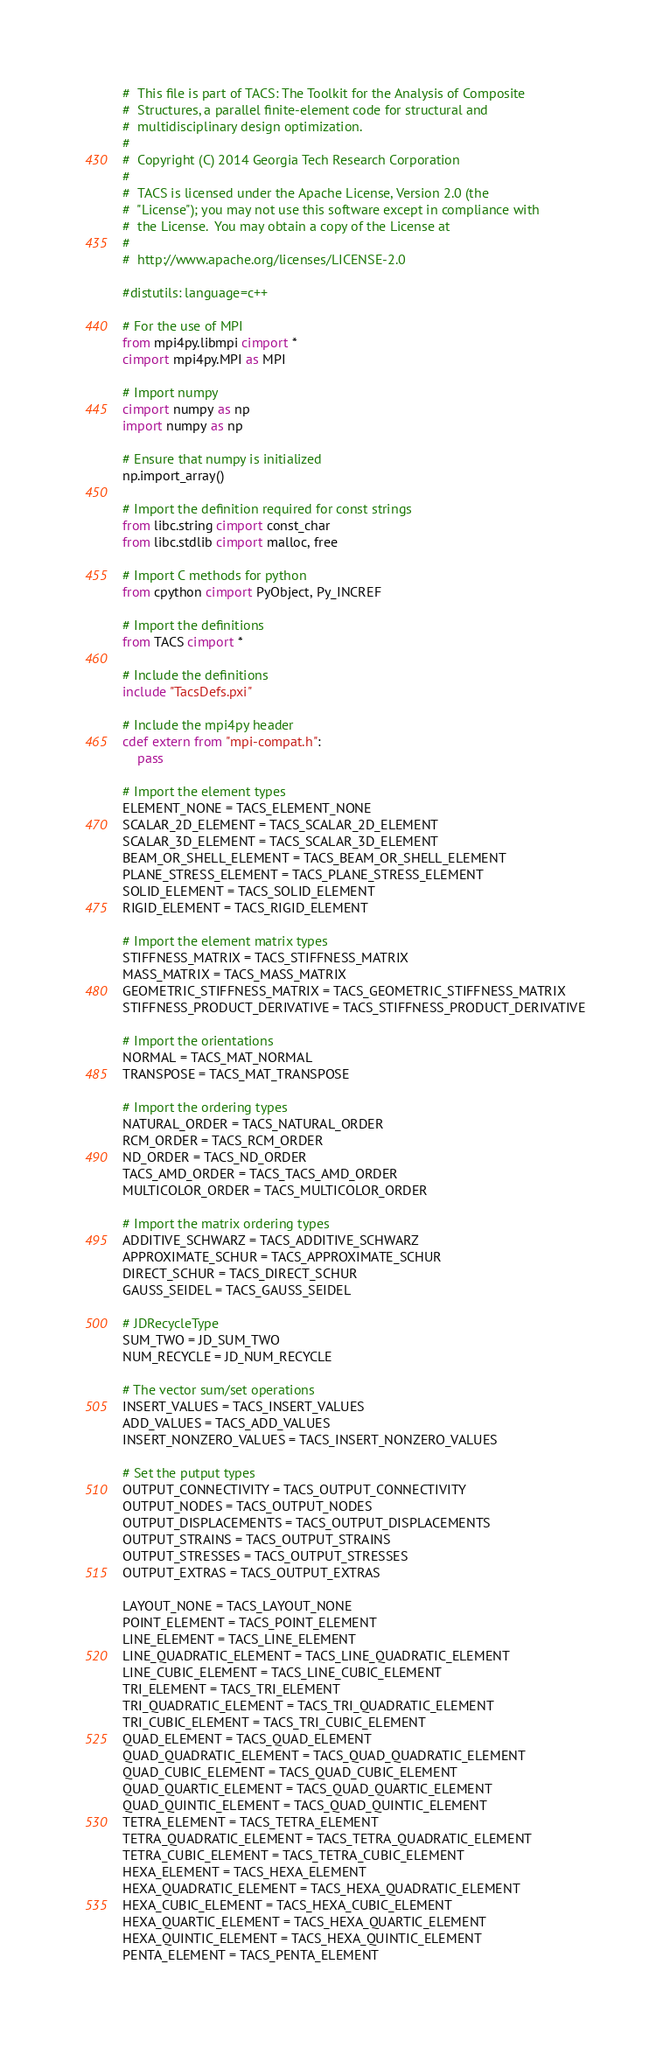<code> <loc_0><loc_0><loc_500><loc_500><_Cython_>#  This file is part of TACS: The Toolkit for the Analysis of Composite
#  Structures, a parallel finite-element code for structural and
#  multidisciplinary design optimization.
#
#  Copyright (C) 2014 Georgia Tech Research Corporation
#
#  TACS is licensed under the Apache License, Version 2.0 (the
#  "License"); you may not use this software except in compliance with
#  the License.  You may obtain a copy of the License at
#
#  http://www.apache.org/licenses/LICENSE-2.0

#distutils: language=c++

# For the use of MPI
from mpi4py.libmpi cimport *
cimport mpi4py.MPI as MPI

# Import numpy
cimport numpy as np
import numpy as np

# Ensure that numpy is initialized
np.import_array()

# Import the definition required for const strings
from libc.string cimport const_char
from libc.stdlib cimport malloc, free

# Import C methods for python
from cpython cimport PyObject, Py_INCREF

# Import the definitions
from TACS cimport *

# Include the definitions
include "TacsDefs.pxi"

# Include the mpi4py header
cdef extern from "mpi-compat.h":
    pass

# Import the element types
ELEMENT_NONE = TACS_ELEMENT_NONE
SCALAR_2D_ELEMENT = TACS_SCALAR_2D_ELEMENT
SCALAR_3D_ELEMENT = TACS_SCALAR_3D_ELEMENT
BEAM_OR_SHELL_ELEMENT = TACS_BEAM_OR_SHELL_ELEMENT
PLANE_STRESS_ELEMENT = TACS_PLANE_STRESS_ELEMENT
SOLID_ELEMENT = TACS_SOLID_ELEMENT
RIGID_ELEMENT = TACS_RIGID_ELEMENT

# Import the element matrix types
STIFFNESS_MATRIX = TACS_STIFFNESS_MATRIX
MASS_MATRIX = TACS_MASS_MATRIX
GEOMETRIC_STIFFNESS_MATRIX = TACS_GEOMETRIC_STIFFNESS_MATRIX
STIFFNESS_PRODUCT_DERIVATIVE = TACS_STIFFNESS_PRODUCT_DERIVATIVE

# Import the orientations
NORMAL = TACS_MAT_NORMAL
TRANSPOSE = TACS_MAT_TRANSPOSE

# Import the ordering types
NATURAL_ORDER = TACS_NATURAL_ORDER
RCM_ORDER = TACS_RCM_ORDER
ND_ORDER = TACS_ND_ORDER
TACS_AMD_ORDER = TACS_TACS_AMD_ORDER
MULTICOLOR_ORDER = TACS_MULTICOLOR_ORDER

# Import the matrix ordering types
ADDITIVE_SCHWARZ = TACS_ADDITIVE_SCHWARZ
APPROXIMATE_SCHUR = TACS_APPROXIMATE_SCHUR
DIRECT_SCHUR = TACS_DIRECT_SCHUR
GAUSS_SEIDEL = TACS_GAUSS_SEIDEL

# JDRecycleType
SUM_TWO = JD_SUM_TWO
NUM_RECYCLE = JD_NUM_RECYCLE

# The vector sum/set operations
INSERT_VALUES = TACS_INSERT_VALUES
ADD_VALUES = TACS_ADD_VALUES
INSERT_NONZERO_VALUES = TACS_INSERT_NONZERO_VALUES

# Set the putput types
OUTPUT_CONNECTIVITY = TACS_OUTPUT_CONNECTIVITY
OUTPUT_NODES = TACS_OUTPUT_NODES
OUTPUT_DISPLACEMENTS = TACS_OUTPUT_DISPLACEMENTS
OUTPUT_STRAINS = TACS_OUTPUT_STRAINS
OUTPUT_STRESSES = TACS_OUTPUT_STRESSES
OUTPUT_EXTRAS = TACS_OUTPUT_EXTRAS

LAYOUT_NONE = TACS_LAYOUT_NONE
POINT_ELEMENT = TACS_POINT_ELEMENT
LINE_ELEMENT = TACS_LINE_ELEMENT
LINE_QUADRATIC_ELEMENT = TACS_LINE_QUADRATIC_ELEMENT
LINE_CUBIC_ELEMENT = TACS_LINE_CUBIC_ELEMENT
TRI_ELEMENT = TACS_TRI_ELEMENT
TRI_QUADRATIC_ELEMENT = TACS_TRI_QUADRATIC_ELEMENT
TRI_CUBIC_ELEMENT = TACS_TRI_CUBIC_ELEMENT
QUAD_ELEMENT = TACS_QUAD_ELEMENT
QUAD_QUADRATIC_ELEMENT = TACS_QUAD_QUADRATIC_ELEMENT
QUAD_CUBIC_ELEMENT = TACS_QUAD_CUBIC_ELEMENT
QUAD_QUARTIC_ELEMENT = TACS_QUAD_QUARTIC_ELEMENT
QUAD_QUINTIC_ELEMENT = TACS_QUAD_QUINTIC_ELEMENT
TETRA_ELEMENT = TACS_TETRA_ELEMENT
TETRA_QUADRATIC_ELEMENT = TACS_TETRA_QUADRATIC_ELEMENT
TETRA_CUBIC_ELEMENT = TACS_TETRA_CUBIC_ELEMENT
HEXA_ELEMENT = TACS_HEXA_ELEMENT
HEXA_QUADRATIC_ELEMENT = TACS_HEXA_QUADRATIC_ELEMENT
HEXA_CUBIC_ELEMENT = TACS_HEXA_CUBIC_ELEMENT
HEXA_QUARTIC_ELEMENT = TACS_HEXA_QUARTIC_ELEMENT
HEXA_QUINTIC_ELEMENT = TACS_HEXA_QUINTIC_ELEMENT
PENTA_ELEMENT = TACS_PENTA_ELEMENT</code> 